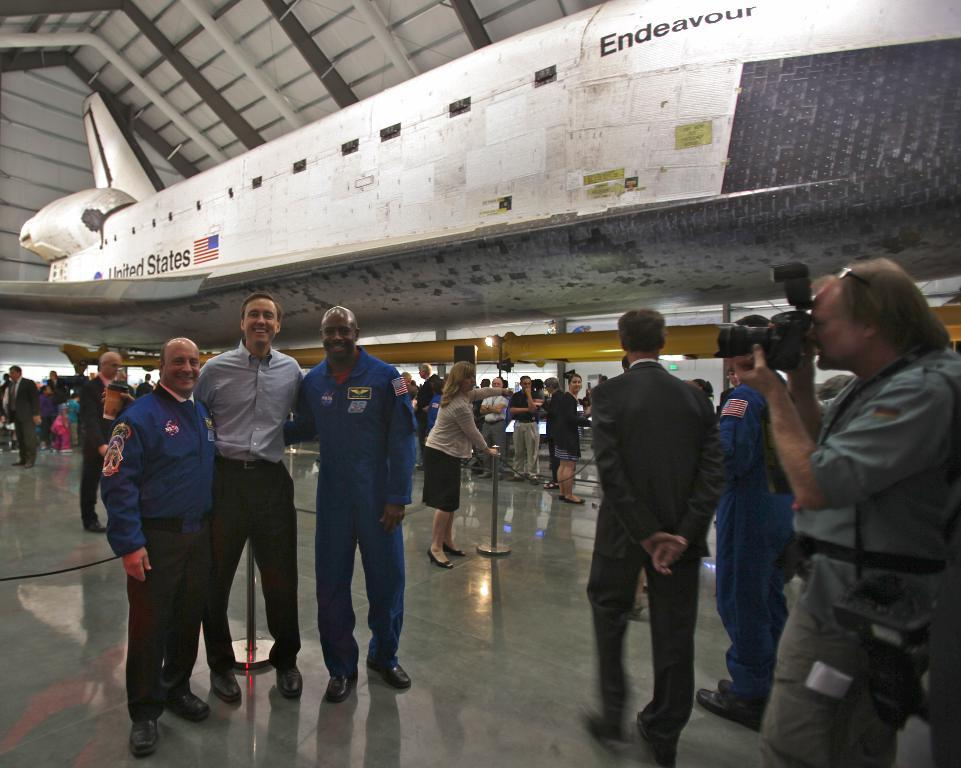<image>
Describe the image concisely. A group of people pose for a photo in front of the United States Endeavour. 